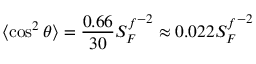Convert formula to latex. <formula><loc_0><loc_0><loc_500><loc_500>\langle \cos ^ { 2 } \theta \rangle = \frac { 0 . 6 6 } { 3 0 } { S _ { F } ^ { f } } ^ { - 2 } \approx 0 . 0 2 2 { S _ { F } ^ { f } } ^ { - 2 }</formula> 